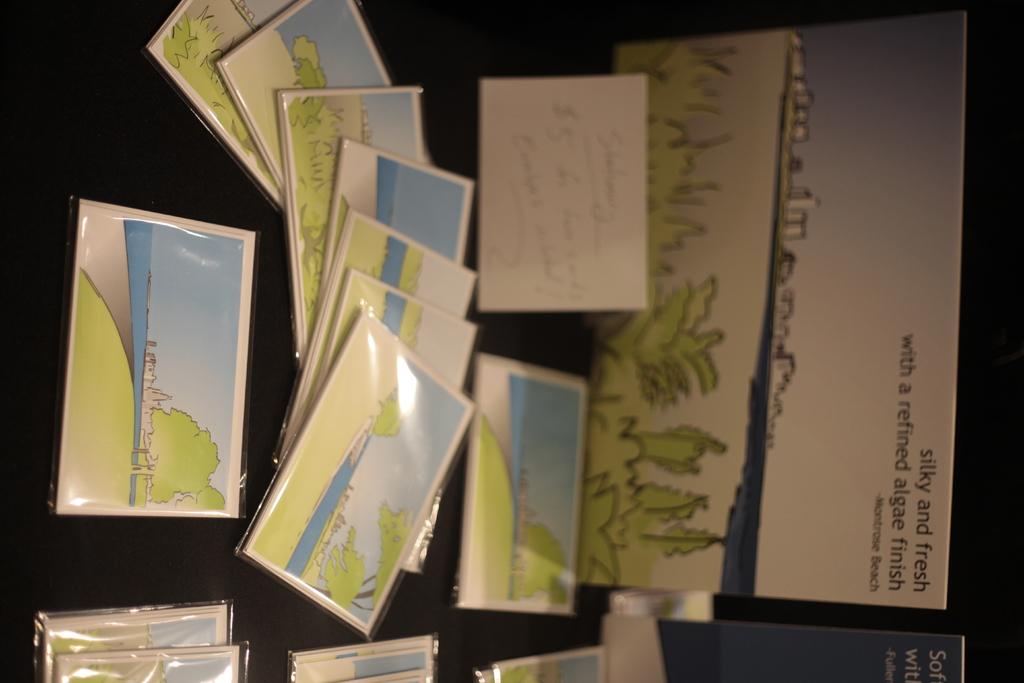What type of finish?
Your answer should be very brief. Refined algae. What is written on any of the materials shown?
Your answer should be compact. Silky and fresh. 